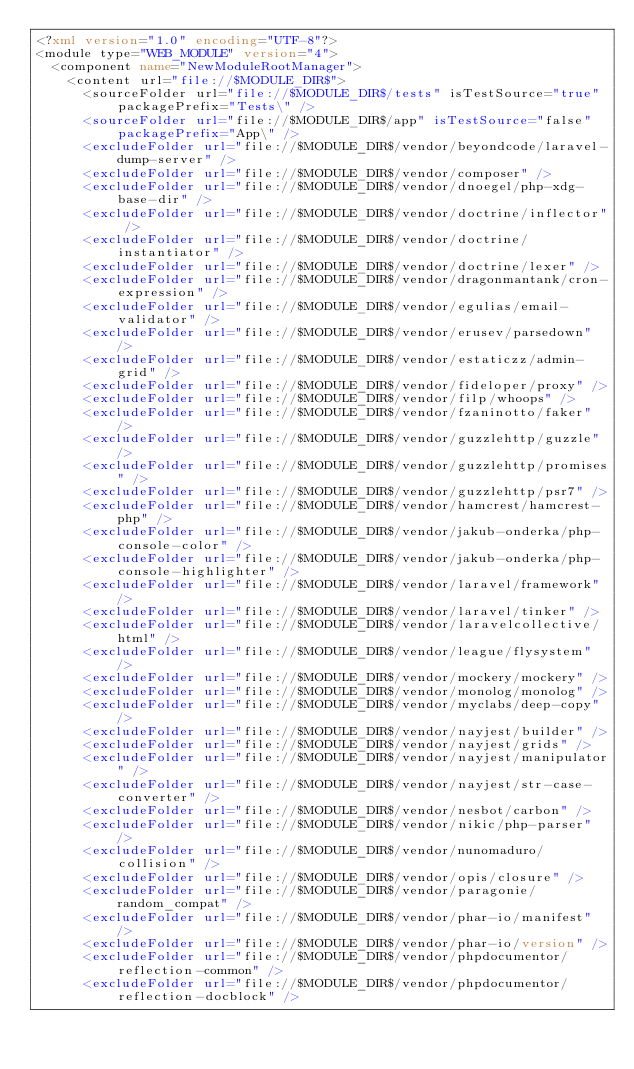Convert code to text. <code><loc_0><loc_0><loc_500><loc_500><_XML_><?xml version="1.0" encoding="UTF-8"?>
<module type="WEB_MODULE" version="4">
  <component name="NewModuleRootManager">
    <content url="file://$MODULE_DIR$">
      <sourceFolder url="file://$MODULE_DIR$/tests" isTestSource="true" packagePrefix="Tests\" />
      <sourceFolder url="file://$MODULE_DIR$/app" isTestSource="false" packagePrefix="App\" />
      <excludeFolder url="file://$MODULE_DIR$/vendor/beyondcode/laravel-dump-server" />
      <excludeFolder url="file://$MODULE_DIR$/vendor/composer" />
      <excludeFolder url="file://$MODULE_DIR$/vendor/dnoegel/php-xdg-base-dir" />
      <excludeFolder url="file://$MODULE_DIR$/vendor/doctrine/inflector" />
      <excludeFolder url="file://$MODULE_DIR$/vendor/doctrine/instantiator" />
      <excludeFolder url="file://$MODULE_DIR$/vendor/doctrine/lexer" />
      <excludeFolder url="file://$MODULE_DIR$/vendor/dragonmantank/cron-expression" />
      <excludeFolder url="file://$MODULE_DIR$/vendor/egulias/email-validator" />
      <excludeFolder url="file://$MODULE_DIR$/vendor/erusev/parsedown" />
      <excludeFolder url="file://$MODULE_DIR$/vendor/estaticzz/admin-grid" />
      <excludeFolder url="file://$MODULE_DIR$/vendor/fideloper/proxy" />
      <excludeFolder url="file://$MODULE_DIR$/vendor/filp/whoops" />
      <excludeFolder url="file://$MODULE_DIR$/vendor/fzaninotto/faker" />
      <excludeFolder url="file://$MODULE_DIR$/vendor/guzzlehttp/guzzle" />
      <excludeFolder url="file://$MODULE_DIR$/vendor/guzzlehttp/promises" />
      <excludeFolder url="file://$MODULE_DIR$/vendor/guzzlehttp/psr7" />
      <excludeFolder url="file://$MODULE_DIR$/vendor/hamcrest/hamcrest-php" />
      <excludeFolder url="file://$MODULE_DIR$/vendor/jakub-onderka/php-console-color" />
      <excludeFolder url="file://$MODULE_DIR$/vendor/jakub-onderka/php-console-highlighter" />
      <excludeFolder url="file://$MODULE_DIR$/vendor/laravel/framework" />
      <excludeFolder url="file://$MODULE_DIR$/vendor/laravel/tinker" />
      <excludeFolder url="file://$MODULE_DIR$/vendor/laravelcollective/html" />
      <excludeFolder url="file://$MODULE_DIR$/vendor/league/flysystem" />
      <excludeFolder url="file://$MODULE_DIR$/vendor/mockery/mockery" />
      <excludeFolder url="file://$MODULE_DIR$/vendor/monolog/monolog" />
      <excludeFolder url="file://$MODULE_DIR$/vendor/myclabs/deep-copy" />
      <excludeFolder url="file://$MODULE_DIR$/vendor/nayjest/builder" />
      <excludeFolder url="file://$MODULE_DIR$/vendor/nayjest/grids" />
      <excludeFolder url="file://$MODULE_DIR$/vendor/nayjest/manipulator" />
      <excludeFolder url="file://$MODULE_DIR$/vendor/nayjest/str-case-converter" />
      <excludeFolder url="file://$MODULE_DIR$/vendor/nesbot/carbon" />
      <excludeFolder url="file://$MODULE_DIR$/vendor/nikic/php-parser" />
      <excludeFolder url="file://$MODULE_DIR$/vendor/nunomaduro/collision" />
      <excludeFolder url="file://$MODULE_DIR$/vendor/opis/closure" />
      <excludeFolder url="file://$MODULE_DIR$/vendor/paragonie/random_compat" />
      <excludeFolder url="file://$MODULE_DIR$/vendor/phar-io/manifest" />
      <excludeFolder url="file://$MODULE_DIR$/vendor/phar-io/version" />
      <excludeFolder url="file://$MODULE_DIR$/vendor/phpdocumentor/reflection-common" />
      <excludeFolder url="file://$MODULE_DIR$/vendor/phpdocumentor/reflection-docblock" /></code> 